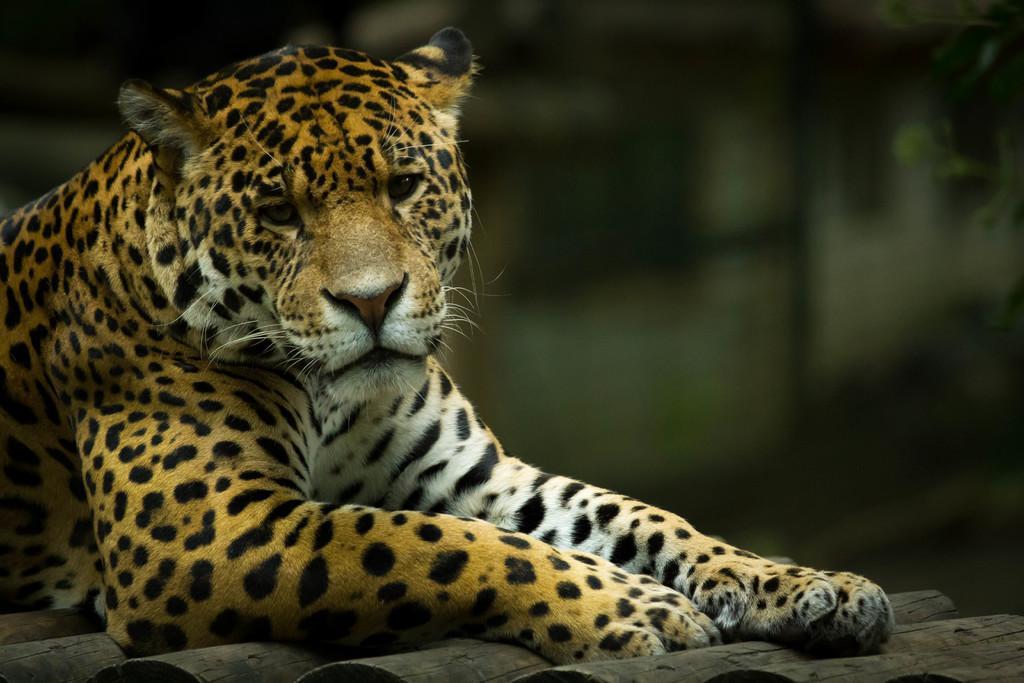In one or two sentences, can you explain what this image depicts? This picture contains cheetah which is sitting on the wooden sticks. In the background, it is green in color and it is blurred. This picture might be clicked in the forest. 